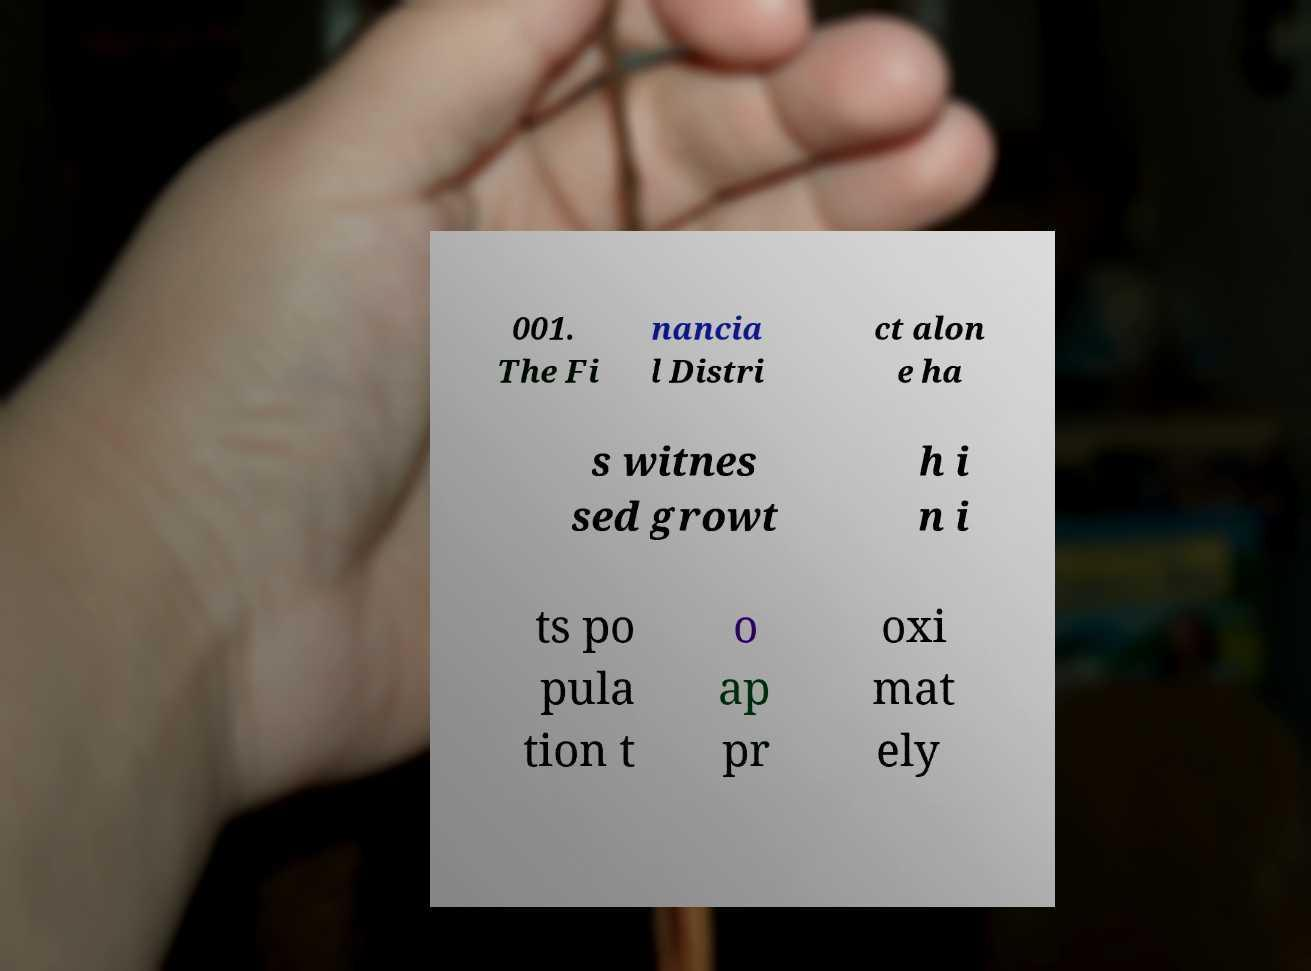Could you assist in decoding the text presented in this image and type it out clearly? 001. The Fi nancia l Distri ct alon e ha s witnes sed growt h i n i ts po pula tion t o ap pr oxi mat ely 